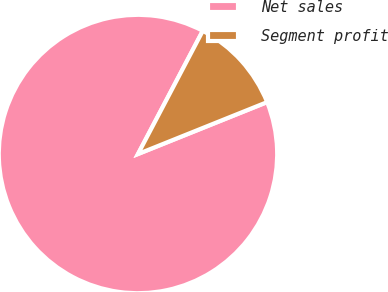Convert chart to OTSL. <chart><loc_0><loc_0><loc_500><loc_500><pie_chart><fcel>Net sales<fcel>Segment profit<nl><fcel>88.79%<fcel>11.21%<nl></chart> 